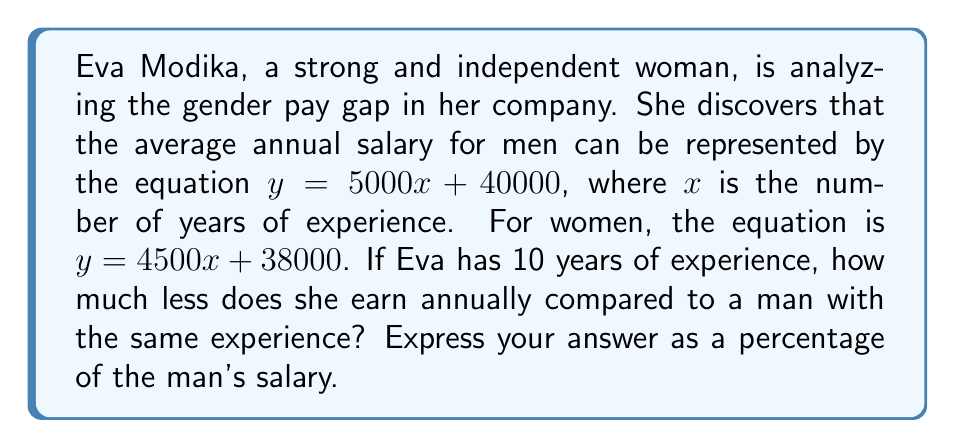Help me with this question. Let's approach this step-by-step:

1) First, let's calculate the salary for a man with 10 years of experience:
   $$y_m = 5000(10) + 40000 = 90000$$

2) Now, let's calculate Eva's salary with 10 years of experience:
   $$y_w = 4500(10) + 38000 = 83000$$

3) To find the difference, we subtract Eva's salary from the man's salary:
   $$\text{Difference} = 90000 - 83000 = 7000$$

4) To express this as a percentage of the man's salary, we use the formula:
   $$\text{Percentage} = \frac{\text{Difference}}{\text{Man's Salary}} \times 100\%$$

5) Plugging in our values:
   $$\text{Percentage} = \frac{7000}{90000} \times 100\% = 0.0778 \times 100\% = 7.78\%$$

Therefore, Eva earns 7.78% less than a man with the same experience in her company.
Answer: 7.78% 